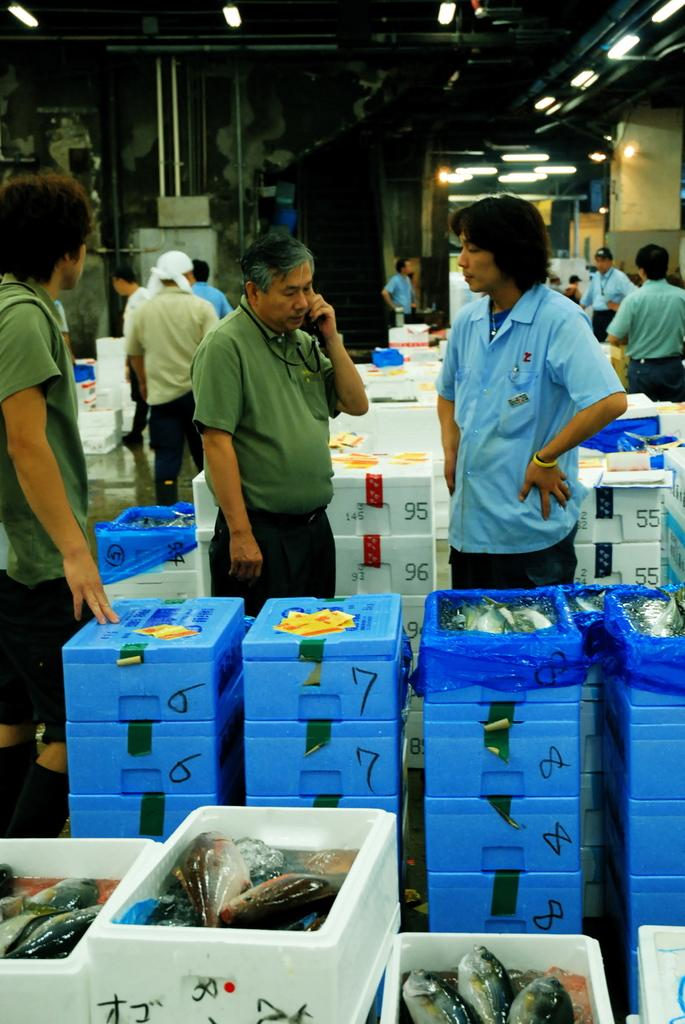How many people are in the image? There is a group of people in the image, but the exact number is not specified. What are the people doing in the image? The people are standing on the floor in the image. What can be seen inside the boxes in the image? There are boxes with fishes in the image. What objects can be seen in the background of the image? There are rods and lights in the background of the image. How many houses are visible in the image? There are no houses visible in the image. What effect does the basin have on the people in the image? There is no basin present in the image, so it cannot have any effect on the people. 